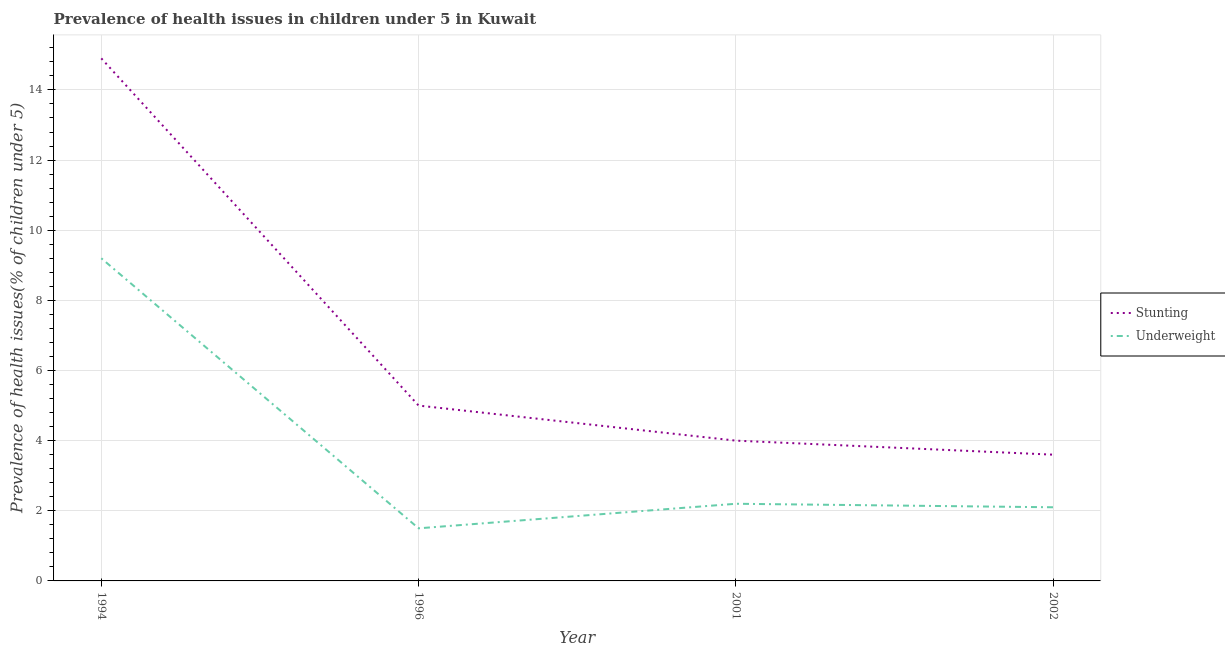Does the line corresponding to percentage of underweight children intersect with the line corresponding to percentage of stunted children?
Provide a short and direct response. No. What is the percentage of underweight children in 2001?
Provide a short and direct response. 2.2. Across all years, what is the maximum percentage of stunted children?
Keep it short and to the point. 14.9. Across all years, what is the minimum percentage of underweight children?
Make the answer very short. 1.5. In which year was the percentage of underweight children maximum?
Offer a very short reply. 1994. What is the total percentage of stunted children in the graph?
Keep it short and to the point. 27.5. What is the difference between the percentage of underweight children in 1996 and that in 2001?
Make the answer very short. -0.7. What is the difference between the percentage of stunted children in 1994 and the percentage of underweight children in 2002?
Provide a short and direct response. 12.8. What is the average percentage of stunted children per year?
Provide a succinct answer. 6.87. In the year 2002, what is the difference between the percentage of stunted children and percentage of underweight children?
Make the answer very short. 1.5. What is the ratio of the percentage of underweight children in 1996 to that in 2002?
Your answer should be very brief. 0.71. Is the percentage of stunted children in 1996 less than that in 2001?
Keep it short and to the point. No. Is the difference between the percentage of stunted children in 2001 and 2002 greater than the difference between the percentage of underweight children in 2001 and 2002?
Your response must be concise. Yes. What is the difference between the highest and the second highest percentage of underweight children?
Make the answer very short. 7. What is the difference between the highest and the lowest percentage of underweight children?
Give a very brief answer. 7.7. Is the sum of the percentage of stunted children in 1994 and 2002 greater than the maximum percentage of underweight children across all years?
Your answer should be compact. Yes. Is the percentage of stunted children strictly greater than the percentage of underweight children over the years?
Offer a very short reply. Yes. Is the percentage of stunted children strictly less than the percentage of underweight children over the years?
Your response must be concise. No. How many lines are there?
Give a very brief answer. 2. How many years are there in the graph?
Your answer should be very brief. 4. Are the values on the major ticks of Y-axis written in scientific E-notation?
Your response must be concise. No. Does the graph contain any zero values?
Make the answer very short. No. Does the graph contain grids?
Your answer should be compact. Yes. What is the title of the graph?
Keep it short and to the point. Prevalence of health issues in children under 5 in Kuwait. Does "Young" appear as one of the legend labels in the graph?
Give a very brief answer. No. What is the label or title of the X-axis?
Your answer should be compact. Year. What is the label or title of the Y-axis?
Offer a terse response. Prevalence of health issues(% of children under 5). What is the Prevalence of health issues(% of children under 5) of Stunting in 1994?
Provide a succinct answer. 14.9. What is the Prevalence of health issues(% of children under 5) of Underweight in 1994?
Your answer should be very brief. 9.2. What is the Prevalence of health issues(% of children under 5) of Stunting in 1996?
Your answer should be very brief. 5. What is the Prevalence of health issues(% of children under 5) of Underweight in 1996?
Your answer should be compact. 1.5. What is the Prevalence of health issues(% of children under 5) in Stunting in 2001?
Your response must be concise. 4. What is the Prevalence of health issues(% of children under 5) of Underweight in 2001?
Provide a succinct answer. 2.2. What is the Prevalence of health issues(% of children under 5) of Stunting in 2002?
Provide a short and direct response. 3.6. What is the Prevalence of health issues(% of children under 5) in Underweight in 2002?
Your answer should be compact. 2.1. Across all years, what is the maximum Prevalence of health issues(% of children under 5) of Stunting?
Provide a short and direct response. 14.9. Across all years, what is the maximum Prevalence of health issues(% of children under 5) of Underweight?
Provide a succinct answer. 9.2. Across all years, what is the minimum Prevalence of health issues(% of children under 5) in Stunting?
Ensure brevity in your answer.  3.6. What is the total Prevalence of health issues(% of children under 5) of Underweight in the graph?
Give a very brief answer. 15. What is the difference between the Prevalence of health issues(% of children under 5) of Stunting in 1994 and that in 2001?
Keep it short and to the point. 10.9. What is the difference between the Prevalence of health issues(% of children under 5) in Underweight in 1994 and that in 2001?
Your answer should be compact. 7. What is the difference between the Prevalence of health issues(% of children under 5) of Stunting in 1996 and that in 2002?
Make the answer very short. 1.4. What is the difference between the Prevalence of health issues(% of children under 5) of Underweight in 1996 and that in 2002?
Offer a terse response. -0.6. What is the difference between the Prevalence of health issues(% of children under 5) in Stunting in 2001 and that in 2002?
Offer a terse response. 0.4. What is the difference between the Prevalence of health issues(% of children under 5) of Underweight in 2001 and that in 2002?
Your answer should be very brief. 0.1. What is the difference between the Prevalence of health issues(% of children under 5) of Stunting in 1994 and the Prevalence of health issues(% of children under 5) of Underweight in 1996?
Keep it short and to the point. 13.4. What is the difference between the Prevalence of health issues(% of children under 5) in Stunting in 1994 and the Prevalence of health issues(% of children under 5) in Underweight in 2001?
Your response must be concise. 12.7. What is the difference between the Prevalence of health issues(% of children under 5) in Stunting in 1996 and the Prevalence of health issues(% of children under 5) in Underweight in 2001?
Your answer should be compact. 2.8. What is the difference between the Prevalence of health issues(% of children under 5) of Stunting in 1996 and the Prevalence of health issues(% of children under 5) of Underweight in 2002?
Ensure brevity in your answer.  2.9. What is the average Prevalence of health issues(% of children under 5) in Stunting per year?
Your answer should be very brief. 6.88. What is the average Prevalence of health issues(% of children under 5) in Underweight per year?
Your answer should be very brief. 3.75. In the year 1994, what is the difference between the Prevalence of health issues(% of children under 5) of Stunting and Prevalence of health issues(% of children under 5) of Underweight?
Keep it short and to the point. 5.7. In the year 2001, what is the difference between the Prevalence of health issues(% of children under 5) of Stunting and Prevalence of health issues(% of children under 5) of Underweight?
Offer a terse response. 1.8. In the year 2002, what is the difference between the Prevalence of health issues(% of children under 5) of Stunting and Prevalence of health issues(% of children under 5) of Underweight?
Your answer should be very brief. 1.5. What is the ratio of the Prevalence of health issues(% of children under 5) in Stunting in 1994 to that in 1996?
Your answer should be compact. 2.98. What is the ratio of the Prevalence of health issues(% of children under 5) of Underweight in 1994 to that in 1996?
Your response must be concise. 6.13. What is the ratio of the Prevalence of health issues(% of children under 5) of Stunting in 1994 to that in 2001?
Provide a short and direct response. 3.73. What is the ratio of the Prevalence of health issues(% of children under 5) in Underweight in 1994 to that in 2001?
Your response must be concise. 4.18. What is the ratio of the Prevalence of health issues(% of children under 5) of Stunting in 1994 to that in 2002?
Give a very brief answer. 4.14. What is the ratio of the Prevalence of health issues(% of children under 5) of Underweight in 1994 to that in 2002?
Your answer should be very brief. 4.38. What is the ratio of the Prevalence of health issues(% of children under 5) of Underweight in 1996 to that in 2001?
Offer a very short reply. 0.68. What is the ratio of the Prevalence of health issues(% of children under 5) of Stunting in 1996 to that in 2002?
Give a very brief answer. 1.39. What is the ratio of the Prevalence of health issues(% of children under 5) in Underweight in 2001 to that in 2002?
Offer a very short reply. 1.05. What is the difference between the highest and the lowest Prevalence of health issues(% of children under 5) of Underweight?
Ensure brevity in your answer.  7.7. 